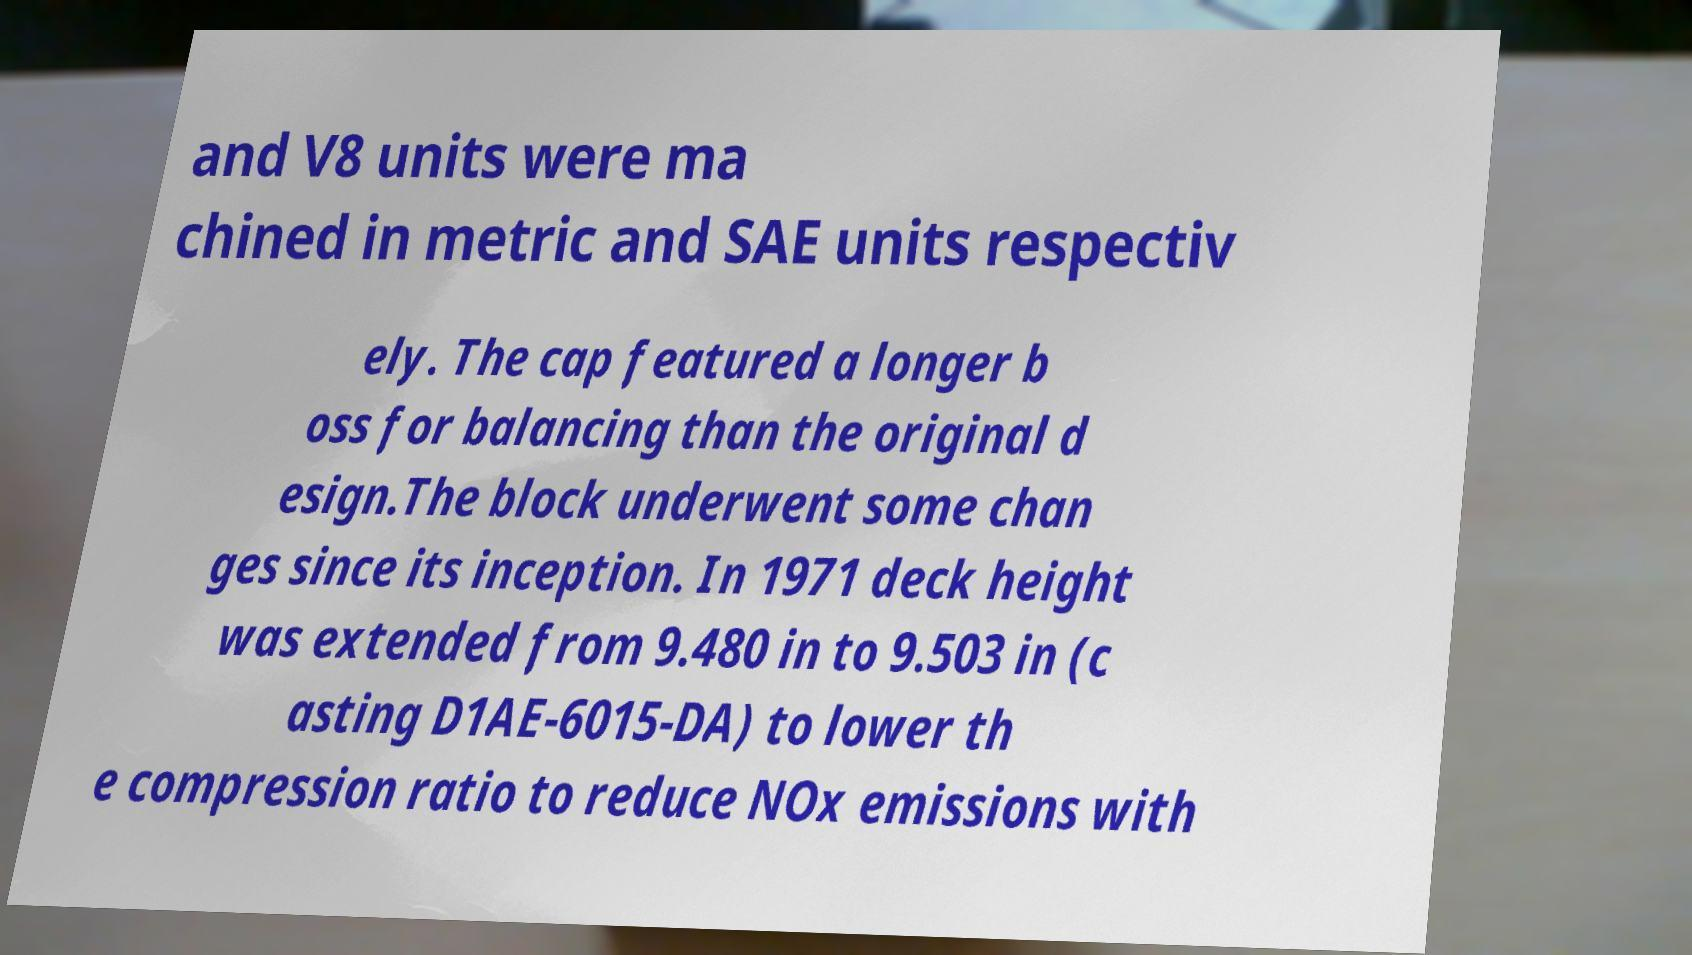Can you accurately transcribe the text from the provided image for me? and V8 units were ma chined in metric and SAE units respectiv ely. The cap featured a longer b oss for balancing than the original d esign.The block underwent some chan ges since its inception. In 1971 deck height was extended from 9.480 in to 9.503 in (c asting D1AE-6015-DA) to lower th e compression ratio to reduce NOx emissions with 